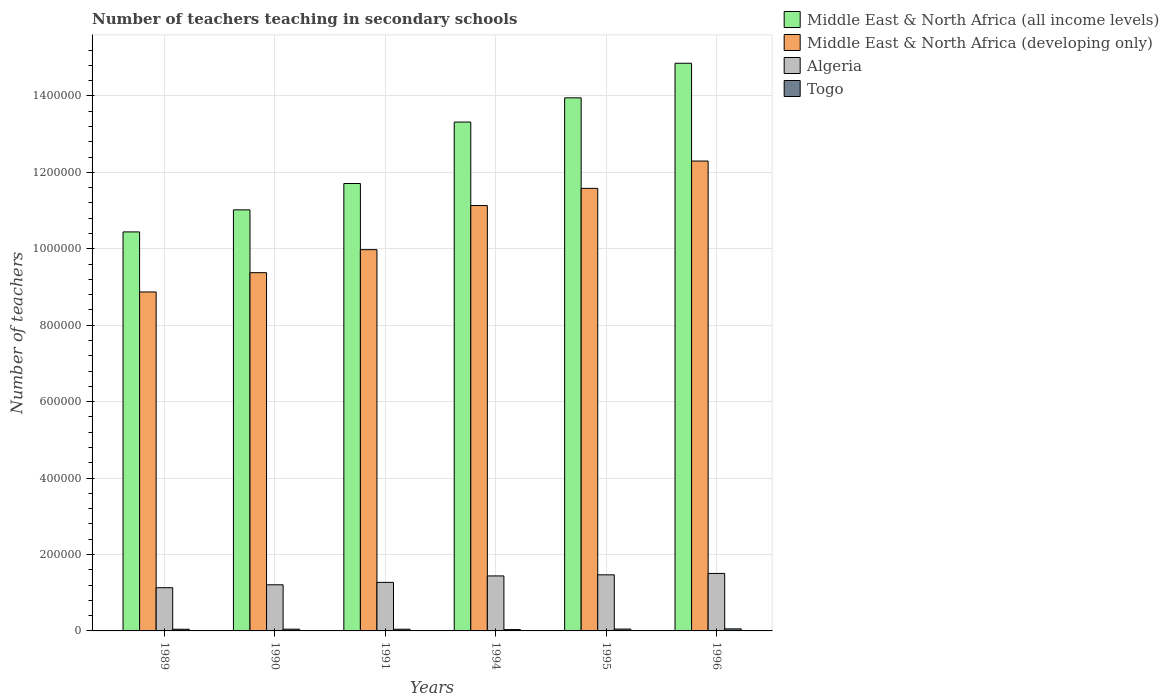How many groups of bars are there?
Your answer should be compact. 6. Are the number of bars per tick equal to the number of legend labels?
Provide a short and direct response. Yes. How many bars are there on the 6th tick from the right?
Provide a succinct answer. 4. What is the label of the 6th group of bars from the left?
Give a very brief answer. 1996. What is the number of teachers teaching in secondary schools in Middle East & North Africa (all income levels) in 1995?
Give a very brief answer. 1.39e+06. Across all years, what is the maximum number of teachers teaching in secondary schools in Togo?
Offer a terse response. 5389. Across all years, what is the minimum number of teachers teaching in secondary schools in Algeria?
Your response must be concise. 1.13e+05. What is the total number of teachers teaching in secondary schools in Togo in the graph?
Your answer should be compact. 2.72e+04. What is the difference between the number of teachers teaching in secondary schools in Middle East & North Africa (all income levels) in 1991 and that in 1996?
Your response must be concise. -3.15e+05. What is the difference between the number of teachers teaching in secondary schools in Togo in 1991 and the number of teachers teaching in secondary schools in Middle East & North Africa (all income levels) in 1996?
Your answer should be compact. -1.48e+06. What is the average number of teachers teaching in secondary schools in Middle East & North Africa (all income levels) per year?
Provide a succinct answer. 1.25e+06. In the year 1990, what is the difference between the number of teachers teaching in secondary schools in Togo and number of teachers teaching in secondary schools in Algeria?
Make the answer very short. -1.16e+05. In how many years, is the number of teachers teaching in secondary schools in Middle East & North Africa (developing only) greater than 200000?
Your response must be concise. 6. What is the ratio of the number of teachers teaching in secondary schools in Middle East & North Africa (all income levels) in 1990 to that in 1991?
Make the answer very short. 0.94. Is the number of teachers teaching in secondary schools in Middle East & North Africa (all income levels) in 1994 less than that in 1995?
Make the answer very short. Yes. What is the difference between the highest and the second highest number of teachers teaching in secondary schools in Middle East & North Africa (all income levels)?
Offer a terse response. 9.05e+04. What is the difference between the highest and the lowest number of teachers teaching in secondary schools in Middle East & North Africa (developing only)?
Ensure brevity in your answer.  3.43e+05. In how many years, is the number of teachers teaching in secondary schools in Algeria greater than the average number of teachers teaching in secondary schools in Algeria taken over all years?
Your answer should be very brief. 3. Is the sum of the number of teachers teaching in secondary schools in Algeria in 1991 and 1996 greater than the maximum number of teachers teaching in secondary schools in Middle East & North Africa (all income levels) across all years?
Provide a succinct answer. No. What does the 2nd bar from the left in 1995 represents?
Offer a terse response. Middle East & North Africa (developing only). What does the 3rd bar from the right in 1989 represents?
Offer a very short reply. Middle East & North Africa (developing only). Is it the case that in every year, the sum of the number of teachers teaching in secondary schools in Algeria and number of teachers teaching in secondary schools in Middle East & North Africa (all income levels) is greater than the number of teachers teaching in secondary schools in Togo?
Your answer should be compact. Yes. How many bars are there?
Make the answer very short. 24. What is the difference between two consecutive major ticks on the Y-axis?
Keep it short and to the point. 2.00e+05. Are the values on the major ticks of Y-axis written in scientific E-notation?
Your response must be concise. No. Does the graph contain grids?
Give a very brief answer. Yes. How are the legend labels stacked?
Provide a succinct answer. Vertical. What is the title of the graph?
Offer a terse response. Number of teachers teaching in secondary schools. What is the label or title of the X-axis?
Provide a short and direct response. Years. What is the label or title of the Y-axis?
Provide a short and direct response. Number of teachers. What is the Number of teachers in Middle East & North Africa (all income levels) in 1989?
Make the answer very short. 1.04e+06. What is the Number of teachers in Middle East & North Africa (developing only) in 1989?
Provide a succinct answer. 8.87e+05. What is the Number of teachers of Algeria in 1989?
Make the answer very short. 1.13e+05. What is the Number of teachers in Togo in 1989?
Make the answer very short. 4423. What is the Number of teachers of Middle East & North Africa (all income levels) in 1990?
Your answer should be very brief. 1.10e+06. What is the Number of teachers of Middle East & North Africa (developing only) in 1990?
Provide a short and direct response. 9.37e+05. What is the Number of teachers in Algeria in 1990?
Your answer should be compact. 1.21e+05. What is the Number of teachers in Togo in 1990?
Your response must be concise. 4553. What is the Number of teachers of Middle East & North Africa (all income levels) in 1991?
Provide a short and direct response. 1.17e+06. What is the Number of teachers of Middle East & North Africa (developing only) in 1991?
Make the answer very short. 9.98e+05. What is the Number of teachers of Algeria in 1991?
Make the answer very short. 1.27e+05. What is the Number of teachers of Togo in 1991?
Keep it short and to the point. 4492. What is the Number of teachers in Middle East & North Africa (all income levels) in 1994?
Your answer should be compact. 1.33e+06. What is the Number of teachers of Middle East & North Africa (developing only) in 1994?
Keep it short and to the point. 1.11e+06. What is the Number of teachers in Algeria in 1994?
Provide a succinct answer. 1.44e+05. What is the Number of teachers in Togo in 1994?
Offer a very short reply. 3513. What is the Number of teachers of Middle East & North Africa (all income levels) in 1995?
Offer a very short reply. 1.39e+06. What is the Number of teachers in Middle East & North Africa (developing only) in 1995?
Your response must be concise. 1.16e+06. What is the Number of teachers of Algeria in 1995?
Provide a succinct answer. 1.47e+05. What is the Number of teachers in Togo in 1995?
Make the answer very short. 4847. What is the Number of teachers of Middle East & North Africa (all income levels) in 1996?
Provide a short and direct response. 1.49e+06. What is the Number of teachers in Middle East & North Africa (developing only) in 1996?
Your response must be concise. 1.23e+06. What is the Number of teachers of Algeria in 1996?
Make the answer very short. 1.50e+05. What is the Number of teachers of Togo in 1996?
Ensure brevity in your answer.  5389. Across all years, what is the maximum Number of teachers in Middle East & North Africa (all income levels)?
Provide a short and direct response. 1.49e+06. Across all years, what is the maximum Number of teachers of Middle East & North Africa (developing only)?
Provide a succinct answer. 1.23e+06. Across all years, what is the maximum Number of teachers of Algeria?
Your answer should be very brief. 1.50e+05. Across all years, what is the maximum Number of teachers in Togo?
Provide a succinct answer. 5389. Across all years, what is the minimum Number of teachers in Middle East & North Africa (all income levels)?
Your response must be concise. 1.04e+06. Across all years, what is the minimum Number of teachers of Middle East & North Africa (developing only)?
Offer a terse response. 8.87e+05. Across all years, what is the minimum Number of teachers in Algeria?
Give a very brief answer. 1.13e+05. Across all years, what is the minimum Number of teachers of Togo?
Ensure brevity in your answer.  3513. What is the total Number of teachers in Middle East & North Africa (all income levels) in the graph?
Your answer should be very brief. 7.53e+06. What is the total Number of teachers in Middle East & North Africa (developing only) in the graph?
Your answer should be compact. 6.32e+06. What is the total Number of teachers in Algeria in the graph?
Offer a terse response. 8.02e+05. What is the total Number of teachers of Togo in the graph?
Give a very brief answer. 2.72e+04. What is the difference between the Number of teachers in Middle East & North Africa (all income levels) in 1989 and that in 1990?
Keep it short and to the point. -5.77e+04. What is the difference between the Number of teachers of Middle East & North Africa (developing only) in 1989 and that in 1990?
Give a very brief answer. -5.04e+04. What is the difference between the Number of teachers in Algeria in 1989 and that in 1990?
Give a very brief answer. -7623. What is the difference between the Number of teachers of Togo in 1989 and that in 1990?
Your answer should be compact. -130. What is the difference between the Number of teachers of Middle East & North Africa (all income levels) in 1989 and that in 1991?
Give a very brief answer. -1.27e+05. What is the difference between the Number of teachers in Middle East & North Africa (developing only) in 1989 and that in 1991?
Offer a very short reply. -1.11e+05. What is the difference between the Number of teachers in Algeria in 1989 and that in 1991?
Provide a succinct answer. -1.39e+04. What is the difference between the Number of teachers of Togo in 1989 and that in 1991?
Give a very brief answer. -69. What is the difference between the Number of teachers of Middle East & North Africa (all income levels) in 1989 and that in 1994?
Provide a short and direct response. -2.87e+05. What is the difference between the Number of teachers in Middle East & North Africa (developing only) in 1989 and that in 1994?
Your answer should be very brief. -2.26e+05. What is the difference between the Number of teachers in Algeria in 1989 and that in 1994?
Keep it short and to the point. -3.08e+04. What is the difference between the Number of teachers in Togo in 1989 and that in 1994?
Ensure brevity in your answer.  910. What is the difference between the Number of teachers of Middle East & North Africa (all income levels) in 1989 and that in 1995?
Keep it short and to the point. -3.51e+05. What is the difference between the Number of teachers in Middle East & North Africa (developing only) in 1989 and that in 1995?
Your answer should be compact. -2.71e+05. What is the difference between the Number of teachers in Algeria in 1989 and that in 1995?
Offer a terse response. -3.37e+04. What is the difference between the Number of teachers of Togo in 1989 and that in 1995?
Keep it short and to the point. -424. What is the difference between the Number of teachers of Middle East & North Africa (all income levels) in 1989 and that in 1996?
Offer a very short reply. -4.41e+05. What is the difference between the Number of teachers of Middle East & North Africa (developing only) in 1989 and that in 1996?
Your answer should be compact. -3.43e+05. What is the difference between the Number of teachers in Algeria in 1989 and that in 1996?
Your response must be concise. -3.73e+04. What is the difference between the Number of teachers of Togo in 1989 and that in 1996?
Offer a terse response. -966. What is the difference between the Number of teachers of Middle East & North Africa (all income levels) in 1990 and that in 1991?
Ensure brevity in your answer.  -6.90e+04. What is the difference between the Number of teachers in Middle East & North Africa (developing only) in 1990 and that in 1991?
Keep it short and to the point. -6.02e+04. What is the difference between the Number of teachers of Algeria in 1990 and that in 1991?
Your response must be concise. -6302. What is the difference between the Number of teachers in Middle East & North Africa (all income levels) in 1990 and that in 1994?
Provide a succinct answer. -2.30e+05. What is the difference between the Number of teachers of Middle East & North Africa (developing only) in 1990 and that in 1994?
Offer a very short reply. -1.76e+05. What is the difference between the Number of teachers of Algeria in 1990 and that in 1994?
Your answer should be compact. -2.32e+04. What is the difference between the Number of teachers of Togo in 1990 and that in 1994?
Ensure brevity in your answer.  1040. What is the difference between the Number of teachers of Middle East & North Africa (all income levels) in 1990 and that in 1995?
Your response must be concise. -2.93e+05. What is the difference between the Number of teachers of Middle East & North Africa (developing only) in 1990 and that in 1995?
Provide a short and direct response. -2.21e+05. What is the difference between the Number of teachers in Algeria in 1990 and that in 1995?
Provide a succinct answer. -2.61e+04. What is the difference between the Number of teachers of Togo in 1990 and that in 1995?
Give a very brief answer. -294. What is the difference between the Number of teachers in Middle East & North Africa (all income levels) in 1990 and that in 1996?
Your answer should be very brief. -3.84e+05. What is the difference between the Number of teachers of Middle East & North Africa (developing only) in 1990 and that in 1996?
Offer a very short reply. -2.92e+05. What is the difference between the Number of teachers of Algeria in 1990 and that in 1996?
Ensure brevity in your answer.  -2.97e+04. What is the difference between the Number of teachers in Togo in 1990 and that in 1996?
Offer a very short reply. -836. What is the difference between the Number of teachers of Middle East & North Africa (all income levels) in 1991 and that in 1994?
Provide a short and direct response. -1.61e+05. What is the difference between the Number of teachers of Middle East & North Africa (developing only) in 1991 and that in 1994?
Your response must be concise. -1.16e+05. What is the difference between the Number of teachers in Algeria in 1991 and that in 1994?
Make the answer very short. -1.69e+04. What is the difference between the Number of teachers in Togo in 1991 and that in 1994?
Make the answer very short. 979. What is the difference between the Number of teachers in Middle East & North Africa (all income levels) in 1991 and that in 1995?
Provide a short and direct response. -2.24e+05. What is the difference between the Number of teachers in Middle East & North Africa (developing only) in 1991 and that in 1995?
Keep it short and to the point. -1.60e+05. What is the difference between the Number of teachers in Algeria in 1991 and that in 1995?
Your answer should be compact. -1.98e+04. What is the difference between the Number of teachers in Togo in 1991 and that in 1995?
Provide a succinct answer. -355. What is the difference between the Number of teachers in Middle East & North Africa (all income levels) in 1991 and that in 1996?
Provide a succinct answer. -3.15e+05. What is the difference between the Number of teachers of Middle East & North Africa (developing only) in 1991 and that in 1996?
Provide a succinct answer. -2.32e+05. What is the difference between the Number of teachers of Algeria in 1991 and that in 1996?
Your answer should be very brief. -2.34e+04. What is the difference between the Number of teachers in Togo in 1991 and that in 1996?
Keep it short and to the point. -897. What is the difference between the Number of teachers in Middle East & North Africa (all income levels) in 1994 and that in 1995?
Keep it short and to the point. -6.34e+04. What is the difference between the Number of teachers in Middle East & North Africa (developing only) in 1994 and that in 1995?
Ensure brevity in your answer.  -4.49e+04. What is the difference between the Number of teachers in Algeria in 1994 and that in 1995?
Your response must be concise. -2905. What is the difference between the Number of teachers of Togo in 1994 and that in 1995?
Provide a succinct answer. -1334. What is the difference between the Number of teachers of Middle East & North Africa (all income levels) in 1994 and that in 1996?
Your answer should be compact. -1.54e+05. What is the difference between the Number of teachers of Middle East & North Africa (developing only) in 1994 and that in 1996?
Provide a succinct answer. -1.16e+05. What is the difference between the Number of teachers of Algeria in 1994 and that in 1996?
Ensure brevity in your answer.  -6510. What is the difference between the Number of teachers of Togo in 1994 and that in 1996?
Your answer should be very brief. -1876. What is the difference between the Number of teachers of Middle East & North Africa (all income levels) in 1995 and that in 1996?
Ensure brevity in your answer.  -9.05e+04. What is the difference between the Number of teachers of Middle East & North Africa (developing only) in 1995 and that in 1996?
Provide a succinct answer. -7.15e+04. What is the difference between the Number of teachers of Algeria in 1995 and that in 1996?
Provide a succinct answer. -3605. What is the difference between the Number of teachers of Togo in 1995 and that in 1996?
Your answer should be very brief. -542. What is the difference between the Number of teachers of Middle East & North Africa (all income levels) in 1989 and the Number of teachers of Middle East & North Africa (developing only) in 1990?
Ensure brevity in your answer.  1.07e+05. What is the difference between the Number of teachers of Middle East & North Africa (all income levels) in 1989 and the Number of teachers of Algeria in 1990?
Offer a very short reply. 9.23e+05. What is the difference between the Number of teachers in Middle East & North Africa (all income levels) in 1989 and the Number of teachers in Togo in 1990?
Your answer should be compact. 1.04e+06. What is the difference between the Number of teachers of Middle East & North Africa (developing only) in 1989 and the Number of teachers of Algeria in 1990?
Your response must be concise. 7.66e+05. What is the difference between the Number of teachers of Middle East & North Africa (developing only) in 1989 and the Number of teachers of Togo in 1990?
Ensure brevity in your answer.  8.82e+05. What is the difference between the Number of teachers of Algeria in 1989 and the Number of teachers of Togo in 1990?
Provide a succinct answer. 1.09e+05. What is the difference between the Number of teachers of Middle East & North Africa (all income levels) in 1989 and the Number of teachers of Middle East & North Africa (developing only) in 1991?
Offer a very short reply. 4.65e+04. What is the difference between the Number of teachers in Middle East & North Africa (all income levels) in 1989 and the Number of teachers in Algeria in 1991?
Provide a succinct answer. 9.17e+05. What is the difference between the Number of teachers in Middle East & North Africa (all income levels) in 1989 and the Number of teachers in Togo in 1991?
Offer a terse response. 1.04e+06. What is the difference between the Number of teachers in Middle East & North Africa (developing only) in 1989 and the Number of teachers in Algeria in 1991?
Offer a terse response. 7.60e+05. What is the difference between the Number of teachers of Middle East & North Africa (developing only) in 1989 and the Number of teachers of Togo in 1991?
Make the answer very short. 8.82e+05. What is the difference between the Number of teachers in Algeria in 1989 and the Number of teachers in Togo in 1991?
Ensure brevity in your answer.  1.09e+05. What is the difference between the Number of teachers of Middle East & North Africa (all income levels) in 1989 and the Number of teachers of Middle East & North Africa (developing only) in 1994?
Make the answer very short. -6.90e+04. What is the difference between the Number of teachers of Middle East & North Africa (all income levels) in 1989 and the Number of teachers of Algeria in 1994?
Your answer should be very brief. 9.00e+05. What is the difference between the Number of teachers in Middle East & North Africa (all income levels) in 1989 and the Number of teachers in Togo in 1994?
Make the answer very short. 1.04e+06. What is the difference between the Number of teachers in Middle East & North Africa (developing only) in 1989 and the Number of teachers in Algeria in 1994?
Give a very brief answer. 7.43e+05. What is the difference between the Number of teachers of Middle East & North Africa (developing only) in 1989 and the Number of teachers of Togo in 1994?
Your response must be concise. 8.83e+05. What is the difference between the Number of teachers of Algeria in 1989 and the Number of teachers of Togo in 1994?
Your response must be concise. 1.10e+05. What is the difference between the Number of teachers in Middle East & North Africa (all income levels) in 1989 and the Number of teachers in Middle East & North Africa (developing only) in 1995?
Provide a succinct answer. -1.14e+05. What is the difference between the Number of teachers of Middle East & North Africa (all income levels) in 1989 and the Number of teachers of Algeria in 1995?
Your answer should be very brief. 8.97e+05. What is the difference between the Number of teachers of Middle East & North Africa (all income levels) in 1989 and the Number of teachers of Togo in 1995?
Your response must be concise. 1.04e+06. What is the difference between the Number of teachers in Middle East & North Africa (developing only) in 1989 and the Number of teachers in Algeria in 1995?
Your response must be concise. 7.40e+05. What is the difference between the Number of teachers in Middle East & North Africa (developing only) in 1989 and the Number of teachers in Togo in 1995?
Keep it short and to the point. 8.82e+05. What is the difference between the Number of teachers of Algeria in 1989 and the Number of teachers of Togo in 1995?
Your response must be concise. 1.08e+05. What is the difference between the Number of teachers in Middle East & North Africa (all income levels) in 1989 and the Number of teachers in Middle East & North Africa (developing only) in 1996?
Provide a short and direct response. -1.85e+05. What is the difference between the Number of teachers in Middle East & North Africa (all income levels) in 1989 and the Number of teachers in Algeria in 1996?
Ensure brevity in your answer.  8.94e+05. What is the difference between the Number of teachers in Middle East & North Africa (all income levels) in 1989 and the Number of teachers in Togo in 1996?
Offer a very short reply. 1.04e+06. What is the difference between the Number of teachers in Middle East & North Africa (developing only) in 1989 and the Number of teachers in Algeria in 1996?
Offer a very short reply. 7.37e+05. What is the difference between the Number of teachers of Middle East & North Africa (developing only) in 1989 and the Number of teachers of Togo in 1996?
Offer a terse response. 8.82e+05. What is the difference between the Number of teachers in Algeria in 1989 and the Number of teachers in Togo in 1996?
Your answer should be compact. 1.08e+05. What is the difference between the Number of teachers in Middle East & North Africa (all income levels) in 1990 and the Number of teachers in Middle East & North Africa (developing only) in 1991?
Give a very brief answer. 1.04e+05. What is the difference between the Number of teachers in Middle East & North Africa (all income levels) in 1990 and the Number of teachers in Algeria in 1991?
Your response must be concise. 9.75e+05. What is the difference between the Number of teachers in Middle East & North Africa (all income levels) in 1990 and the Number of teachers in Togo in 1991?
Make the answer very short. 1.10e+06. What is the difference between the Number of teachers in Middle East & North Africa (developing only) in 1990 and the Number of teachers in Algeria in 1991?
Give a very brief answer. 8.10e+05. What is the difference between the Number of teachers in Middle East & North Africa (developing only) in 1990 and the Number of teachers in Togo in 1991?
Give a very brief answer. 9.33e+05. What is the difference between the Number of teachers of Algeria in 1990 and the Number of teachers of Togo in 1991?
Give a very brief answer. 1.16e+05. What is the difference between the Number of teachers in Middle East & North Africa (all income levels) in 1990 and the Number of teachers in Middle East & North Africa (developing only) in 1994?
Your answer should be very brief. -1.13e+04. What is the difference between the Number of teachers in Middle East & North Africa (all income levels) in 1990 and the Number of teachers in Algeria in 1994?
Make the answer very short. 9.58e+05. What is the difference between the Number of teachers of Middle East & North Africa (all income levels) in 1990 and the Number of teachers of Togo in 1994?
Keep it short and to the point. 1.10e+06. What is the difference between the Number of teachers in Middle East & North Africa (developing only) in 1990 and the Number of teachers in Algeria in 1994?
Keep it short and to the point. 7.93e+05. What is the difference between the Number of teachers of Middle East & North Africa (developing only) in 1990 and the Number of teachers of Togo in 1994?
Offer a terse response. 9.34e+05. What is the difference between the Number of teachers of Algeria in 1990 and the Number of teachers of Togo in 1994?
Provide a succinct answer. 1.17e+05. What is the difference between the Number of teachers in Middle East & North Africa (all income levels) in 1990 and the Number of teachers in Middle East & North Africa (developing only) in 1995?
Keep it short and to the point. -5.63e+04. What is the difference between the Number of teachers of Middle East & North Africa (all income levels) in 1990 and the Number of teachers of Algeria in 1995?
Provide a short and direct response. 9.55e+05. What is the difference between the Number of teachers in Middle East & North Africa (all income levels) in 1990 and the Number of teachers in Togo in 1995?
Provide a succinct answer. 1.10e+06. What is the difference between the Number of teachers of Middle East & North Africa (developing only) in 1990 and the Number of teachers of Algeria in 1995?
Offer a very short reply. 7.91e+05. What is the difference between the Number of teachers of Middle East & North Africa (developing only) in 1990 and the Number of teachers of Togo in 1995?
Your response must be concise. 9.33e+05. What is the difference between the Number of teachers in Algeria in 1990 and the Number of teachers in Togo in 1995?
Offer a very short reply. 1.16e+05. What is the difference between the Number of teachers of Middle East & North Africa (all income levels) in 1990 and the Number of teachers of Middle East & North Africa (developing only) in 1996?
Provide a succinct answer. -1.28e+05. What is the difference between the Number of teachers of Middle East & North Africa (all income levels) in 1990 and the Number of teachers of Algeria in 1996?
Give a very brief answer. 9.51e+05. What is the difference between the Number of teachers of Middle East & North Africa (all income levels) in 1990 and the Number of teachers of Togo in 1996?
Ensure brevity in your answer.  1.10e+06. What is the difference between the Number of teachers of Middle East & North Africa (developing only) in 1990 and the Number of teachers of Algeria in 1996?
Ensure brevity in your answer.  7.87e+05. What is the difference between the Number of teachers of Middle East & North Africa (developing only) in 1990 and the Number of teachers of Togo in 1996?
Your answer should be very brief. 9.32e+05. What is the difference between the Number of teachers in Algeria in 1990 and the Number of teachers in Togo in 1996?
Your answer should be compact. 1.15e+05. What is the difference between the Number of teachers in Middle East & North Africa (all income levels) in 1991 and the Number of teachers in Middle East & North Africa (developing only) in 1994?
Provide a short and direct response. 5.76e+04. What is the difference between the Number of teachers of Middle East & North Africa (all income levels) in 1991 and the Number of teachers of Algeria in 1994?
Offer a terse response. 1.03e+06. What is the difference between the Number of teachers in Middle East & North Africa (all income levels) in 1991 and the Number of teachers in Togo in 1994?
Offer a very short reply. 1.17e+06. What is the difference between the Number of teachers of Middle East & North Africa (developing only) in 1991 and the Number of teachers of Algeria in 1994?
Your answer should be compact. 8.54e+05. What is the difference between the Number of teachers in Middle East & North Africa (developing only) in 1991 and the Number of teachers in Togo in 1994?
Provide a succinct answer. 9.94e+05. What is the difference between the Number of teachers in Algeria in 1991 and the Number of teachers in Togo in 1994?
Keep it short and to the point. 1.24e+05. What is the difference between the Number of teachers in Middle East & North Africa (all income levels) in 1991 and the Number of teachers in Middle East & North Africa (developing only) in 1995?
Give a very brief answer. 1.27e+04. What is the difference between the Number of teachers in Middle East & North Africa (all income levels) in 1991 and the Number of teachers in Algeria in 1995?
Your answer should be very brief. 1.02e+06. What is the difference between the Number of teachers of Middle East & North Africa (all income levels) in 1991 and the Number of teachers of Togo in 1995?
Offer a terse response. 1.17e+06. What is the difference between the Number of teachers in Middle East & North Africa (developing only) in 1991 and the Number of teachers in Algeria in 1995?
Your answer should be compact. 8.51e+05. What is the difference between the Number of teachers in Middle East & North Africa (developing only) in 1991 and the Number of teachers in Togo in 1995?
Provide a succinct answer. 9.93e+05. What is the difference between the Number of teachers of Algeria in 1991 and the Number of teachers of Togo in 1995?
Provide a succinct answer. 1.22e+05. What is the difference between the Number of teachers of Middle East & North Africa (all income levels) in 1991 and the Number of teachers of Middle East & North Africa (developing only) in 1996?
Your answer should be compact. -5.88e+04. What is the difference between the Number of teachers of Middle East & North Africa (all income levels) in 1991 and the Number of teachers of Algeria in 1996?
Ensure brevity in your answer.  1.02e+06. What is the difference between the Number of teachers of Middle East & North Africa (all income levels) in 1991 and the Number of teachers of Togo in 1996?
Provide a short and direct response. 1.17e+06. What is the difference between the Number of teachers of Middle East & North Africa (developing only) in 1991 and the Number of teachers of Algeria in 1996?
Keep it short and to the point. 8.47e+05. What is the difference between the Number of teachers in Middle East & North Africa (developing only) in 1991 and the Number of teachers in Togo in 1996?
Provide a succinct answer. 9.92e+05. What is the difference between the Number of teachers of Algeria in 1991 and the Number of teachers of Togo in 1996?
Keep it short and to the point. 1.22e+05. What is the difference between the Number of teachers in Middle East & North Africa (all income levels) in 1994 and the Number of teachers in Middle East & North Africa (developing only) in 1995?
Ensure brevity in your answer.  1.73e+05. What is the difference between the Number of teachers of Middle East & North Africa (all income levels) in 1994 and the Number of teachers of Algeria in 1995?
Your response must be concise. 1.18e+06. What is the difference between the Number of teachers in Middle East & North Africa (all income levels) in 1994 and the Number of teachers in Togo in 1995?
Provide a succinct answer. 1.33e+06. What is the difference between the Number of teachers of Middle East & North Africa (developing only) in 1994 and the Number of teachers of Algeria in 1995?
Keep it short and to the point. 9.66e+05. What is the difference between the Number of teachers in Middle East & North Africa (developing only) in 1994 and the Number of teachers in Togo in 1995?
Provide a short and direct response. 1.11e+06. What is the difference between the Number of teachers in Algeria in 1994 and the Number of teachers in Togo in 1995?
Ensure brevity in your answer.  1.39e+05. What is the difference between the Number of teachers of Middle East & North Africa (all income levels) in 1994 and the Number of teachers of Middle East & North Africa (developing only) in 1996?
Your response must be concise. 1.02e+05. What is the difference between the Number of teachers of Middle East & North Africa (all income levels) in 1994 and the Number of teachers of Algeria in 1996?
Keep it short and to the point. 1.18e+06. What is the difference between the Number of teachers of Middle East & North Africa (all income levels) in 1994 and the Number of teachers of Togo in 1996?
Your answer should be very brief. 1.33e+06. What is the difference between the Number of teachers of Middle East & North Africa (developing only) in 1994 and the Number of teachers of Algeria in 1996?
Give a very brief answer. 9.63e+05. What is the difference between the Number of teachers in Middle East & North Africa (developing only) in 1994 and the Number of teachers in Togo in 1996?
Provide a short and direct response. 1.11e+06. What is the difference between the Number of teachers of Algeria in 1994 and the Number of teachers of Togo in 1996?
Provide a short and direct response. 1.38e+05. What is the difference between the Number of teachers in Middle East & North Africa (all income levels) in 1995 and the Number of teachers in Middle East & North Africa (developing only) in 1996?
Offer a very short reply. 1.65e+05. What is the difference between the Number of teachers in Middle East & North Africa (all income levels) in 1995 and the Number of teachers in Algeria in 1996?
Provide a short and direct response. 1.24e+06. What is the difference between the Number of teachers of Middle East & North Africa (all income levels) in 1995 and the Number of teachers of Togo in 1996?
Provide a succinct answer. 1.39e+06. What is the difference between the Number of teachers of Middle East & North Africa (developing only) in 1995 and the Number of teachers of Algeria in 1996?
Offer a very short reply. 1.01e+06. What is the difference between the Number of teachers of Middle East & North Africa (developing only) in 1995 and the Number of teachers of Togo in 1996?
Give a very brief answer. 1.15e+06. What is the difference between the Number of teachers in Algeria in 1995 and the Number of teachers in Togo in 1996?
Provide a short and direct response. 1.41e+05. What is the average Number of teachers in Middle East & North Africa (all income levels) per year?
Keep it short and to the point. 1.25e+06. What is the average Number of teachers in Middle East & North Africa (developing only) per year?
Keep it short and to the point. 1.05e+06. What is the average Number of teachers in Algeria per year?
Make the answer very short. 1.34e+05. What is the average Number of teachers of Togo per year?
Keep it short and to the point. 4536.17. In the year 1989, what is the difference between the Number of teachers in Middle East & North Africa (all income levels) and Number of teachers in Middle East & North Africa (developing only)?
Keep it short and to the point. 1.57e+05. In the year 1989, what is the difference between the Number of teachers in Middle East & North Africa (all income levels) and Number of teachers in Algeria?
Give a very brief answer. 9.31e+05. In the year 1989, what is the difference between the Number of teachers of Middle East & North Africa (all income levels) and Number of teachers of Togo?
Provide a short and direct response. 1.04e+06. In the year 1989, what is the difference between the Number of teachers of Middle East & North Africa (developing only) and Number of teachers of Algeria?
Provide a succinct answer. 7.74e+05. In the year 1989, what is the difference between the Number of teachers of Middle East & North Africa (developing only) and Number of teachers of Togo?
Ensure brevity in your answer.  8.82e+05. In the year 1989, what is the difference between the Number of teachers in Algeria and Number of teachers in Togo?
Keep it short and to the point. 1.09e+05. In the year 1990, what is the difference between the Number of teachers of Middle East & North Africa (all income levels) and Number of teachers of Middle East & North Africa (developing only)?
Offer a very short reply. 1.64e+05. In the year 1990, what is the difference between the Number of teachers in Middle East & North Africa (all income levels) and Number of teachers in Algeria?
Offer a very short reply. 9.81e+05. In the year 1990, what is the difference between the Number of teachers in Middle East & North Africa (all income levels) and Number of teachers in Togo?
Your answer should be compact. 1.10e+06. In the year 1990, what is the difference between the Number of teachers of Middle East & North Africa (developing only) and Number of teachers of Algeria?
Your answer should be very brief. 8.17e+05. In the year 1990, what is the difference between the Number of teachers of Middle East & North Africa (developing only) and Number of teachers of Togo?
Your answer should be very brief. 9.33e+05. In the year 1990, what is the difference between the Number of teachers of Algeria and Number of teachers of Togo?
Offer a very short reply. 1.16e+05. In the year 1991, what is the difference between the Number of teachers in Middle East & North Africa (all income levels) and Number of teachers in Middle East & North Africa (developing only)?
Make the answer very short. 1.73e+05. In the year 1991, what is the difference between the Number of teachers of Middle East & North Africa (all income levels) and Number of teachers of Algeria?
Your response must be concise. 1.04e+06. In the year 1991, what is the difference between the Number of teachers in Middle East & North Africa (all income levels) and Number of teachers in Togo?
Keep it short and to the point. 1.17e+06. In the year 1991, what is the difference between the Number of teachers of Middle East & North Africa (developing only) and Number of teachers of Algeria?
Your answer should be compact. 8.71e+05. In the year 1991, what is the difference between the Number of teachers of Middle East & North Africa (developing only) and Number of teachers of Togo?
Your answer should be very brief. 9.93e+05. In the year 1991, what is the difference between the Number of teachers in Algeria and Number of teachers in Togo?
Offer a terse response. 1.23e+05. In the year 1994, what is the difference between the Number of teachers in Middle East & North Africa (all income levels) and Number of teachers in Middle East & North Africa (developing only)?
Your answer should be very brief. 2.18e+05. In the year 1994, what is the difference between the Number of teachers in Middle East & North Africa (all income levels) and Number of teachers in Algeria?
Your answer should be compact. 1.19e+06. In the year 1994, what is the difference between the Number of teachers of Middle East & North Africa (all income levels) and Number of teachers of Togo?
Offer a terse response. 1.33e+06. In the year 1994, what is the difference between the Number of teachers in Middle East & North Africa (developing only) and Number of teachers in Algeria?
Your answer should be very brief. 9.69e+05. In the year 1994, what is the difference between the Number of teachers in Middle East & North Africa (developing only) and Number of teachers in Togo?
Offer a terse response. 1.11e+06. In the year 1994, what is the difference between the Number of teachers in Algeria and Number of teachers in Togo?
Make the answer very short. 1.40e+05. In the year 1995, what is the difference between the Number of teachers of Middle East & North Africa (all income levels) and Number of teachers of Middle East & North Africa (developing only)?
Keep it short and to the point. 2.37e+05. In the year 1995, what is the difference between the Number of teachers in Middle East & North Africa (all income levels) and Number of teachers in Algeria?
Your answer should be very brief. 1.25e+06. In the year 1995, what is the difference between the Number of teachers in Middle East & North Africa (all income levels) and Number of teachers in Togo?
Provide a short and direct response. 1.39e+06. In the year 1995, what is the difference between the Number of teachers in Middle East & North Africa (developing only) and Number of teachers in Algeria?
Provide a succinct answer. 1.01e+06. In the year 1995, what is the difference between the Number of teachers of Middle East & North Africa (developing only) and Number of teachers of Togo?
Provide a short and direct response. 1.15e+06. In the year 1995, what is the difference between the Number of teachers of Algeria and Number of teachers of Togo?
Your response must be concise. 1.42e+05. In the year 1996, what is the difference between the Number of teachers in Middle East & North Africa (all income levels) and Number of teachers in Middle East & North Africa (developing only)?
Your answer should be compact. 2.56e+05. In the year 1996, what is the difference between the Number of teachers in Middle East & North Africa (all income levels) and Number of teachers in Algeria?
Your answer should be very brief. 1.33e+06. In the year 1996, what is the difference between the Number of teachers of Middle East & North Africa (all income levels) and Number of teachers of Togo?
Give a very brief answer. 1.48e+06. In the year 1996, what is the difference between the Number of teachers of Middle East & North Africa (developing only) and Number of teachers of Algeria?
Your answer should be very brief. 1.08e+06. In the year 1996, what is the difference between the Number of teachers in Middle East & North Africa (developing only) and Number of teachers in Togo?
Your answer should be very brief. 1.22e+06. In the year 1996, what is the difference between the Number of teachers in Algeria and Number of teachers in Togo?
Provide a succinct answer. 1.45e+05. What is the ratio of the Number of teachers in Middle East & North Africa (all income levels) in 1989 to that in 1990?
Give a very brief answer. 0.95. What is the ratio of the Number of teachers in Middle East & North Africa (developing only) in 1989 to that in 1990?
Offer a terse response. 0.95. What is the ratio of the Number of teachers in Algeria in 1989 to that in 1990?
Offer a terse response. 0.94. What is the ratio of the Number of teachers in Togo in 1989 to that in 1990?
Your answer should be compact. 0.97. What is the ratio of the Number of teachers in Middle East & North Africa (all income levels) in 1989 to that in 1991?
Provide a short and direct response. 0.89. What is the ratio of the Number of teachers in Middle East & North Africa (developing only) in 1989 to that in 1991?
Provide a succinct answer. 0.89. What is the ratio of the Number of teachers of Algeria in 1989 to that in 1991?
Offer a terse response. 0.89. What is the ratio of the Number of teachers in Togo in 1989 to that in 1991?
Provide a short and direct response. 0.98. What is the ratio of the Number of teachers of Middle East & North Africa (all income levels) in 1989 to that in 1994?
Give a very brief answer. 0.78. What is the ratio of the Number of teachers in Middle East & North Africa (developing only) in 1989 to that in 1994?
Your answer should be compact. 0.8. What is the ratio of the Number of teachers of Algeria in 1989 to that in 1994?
Offer a terse response. 0.79. What is the ratio of the Number of teachers of Togo in 1989 to that in 1994?
Offer a very short reply. 1.26. What is the ratio of the Number of teachers in Middle East & North Africa (all income levels) in 1989 to that in 1995?
Make the answer very short. 0.75. What is the ratio of the Number of teachers in Middle East & North Africa (developing only) in 1989 to that in 1995?
Offer a terse response. 0.77. What is the ratio of the Number of teachers of Algeria in 1989 to that in 1995?
Give a very brief answer. 0.77. What is the ratio of the Number of teachers in Togo in 1989 to that in 1995?
Give a very brief answer. 0.91. What is the ratio of the Number of teachers in Middle East & North Africa (all income levels) in 1989 to that in 1996?
Offer a terse response. 0.7. What is the ratio of the Number of teachers of Middle East & North Africa (developing only) in 1989 to that in 1996?
Ensure brevity in your answer.  0.72. What is the ratio of the Number of teachers in Algeria in 1989 to that in 1996?
Ensure brevity in your answer.  0.75. What is the ratio of the Number of teachers in Togo in 1989 to that in 1996?
Provide a succinct answer. 0.82. What is the ratio of the Number of teachers in Middle East & North Africa (all income levels) in 1990 to that in 1991?
Provide a succinct answer. 0.94. What is the ratio of the Number of teachers in Middle East & North Africa (developing only) in 1990 to that in 1991?
Give a very brief answer. 0.94. What is the ratio of the Number of teachers in Algeria in 1990 to that in 1991?
Your answer should be compact. 0.95. What is the ratio of the Number of teachers of Togo in 1990 to that in 1991?
Keep it short and to the point. 1.01. What is the ratio of the Number of teachers in Middle East & North Africa (all income levels) in 1990 to that in 1994?
Your answer should be compact. 0.83. What is the ratio of the Number of teachers of Middle East & North Africa (developing only) in 1990 to that in 1994?
Make the answer very short. 0.84. What is the ratio of the Number of teachers in Algeria in 1990 to that in 1994?
Offer a terse response. 0.84. What is the ratio of the Number of teachers in Togo in 1990 to that in 1994?
Provide a short and direct response. 1.3. What is the ratio of the Number of teachers in Middle East & North Africa (all income levels) in 1990 to that in 1995?
Your answer should be compact. 0.79. What is the ratio of the Number of teachers of Middle East & North Africa (developing only) in 1990 to that in 1995?
Provide a short and direct response. 0.81. What is the ratio of the Number of teachers of Algeria in 1990 to that in 1995?
Your answer should be compact. 0.82. What is the ratio of the Number of teachers in Togo in 1990 to that in 1995?
Give a very brief answer. 0.94. What is the ratio of the Number of teachers in Middle East & North Africa (all income levels) in 1990 to that in 1996?
Make the answer very short. 0.74. What is the ratio of the Number of teachers in Middle East & North Africa (developing only) in 1990 to that in 1996?
Your response must be concise. 0.76. What is the ratio of the Number of teachers in Algeria in 1990 to that in 1996?
Provide a short and direct response. 0.8. What is the ratio of the Number of teachers of Togo in 1990 to that in 1996?
Your answer should be compact. 0.84. What is the ratio of the Number of teachers in Middle East & North Africa (all income levels) in 1991 to that in 1994?
Your answer should be compact. 0.88. What is the ratio of the Number of teachers of Middle East & North Africa (developing only) in 1991 to that in 1994?
Your response must be concise. 0.9. What is the ratio of the Number of teachers in Algeria in 1991 to that in 1994?
Make the answer very short. 0.88. What is the ratio of the Number of teachers of Togo in 1991 to that in 1994?
Your response must be concise. 1.28. What is the ratio of the Number of teachers of Middle East & North Africa (all income levels) in 1991 to that in 1995?
Make the answer very short. 0.84. What is the ratio of the Number of teachers in Middle East & North Africa (developing only) in 1991 to that in 1995?
Give a very brief answer. 0.86. What is the ratio of the Number of teachers in Algeria in 1991 to that in 1995?
Your response must be concise. 0.87. What is the ratio of the Number of teachers in Togo in 1991 to that in 1995?
Make the answer very short. 0.93. What is the ratio of the Number of teachers of Middle East & North Africa (all income levels) in 1991 to that in 1996?
Give a very brief answer. 0.79. What is the ratio of the Number of teachers in Middle East & North Africa (developing only) in 1991 to that in 1996?
Offer a very short reply. 0.81. What is the ratio of the Number of teachers in Algeria in 1991 to that in 1996?
Provide a short and direct response. 0.84. What is the ratio of the Number of teachers in Togo in 1991 to that in 1996?
Provide a succinct answer. 0.83. What is the ratio of the Number of teachers of Middle East & North Africa (all income levels) in 1994 to that in 1995?
Offer a very short reply. 0.95. What is the ratio of the Number of teachers of Middle East & North Africa (developing only) in 1994 to that in 1995?
Provide a succinct answer. 0.96. What is the ratio of the Number of teachers in Algeria in 1994 to that in 1995?
Your response must be concise. 0.98. What is the ratio of the Number of teachers in Togo in 1994 to that in 1995?
Give a very brief answer. 0.72. What is the ratio of the Number of teachers of Middle East & North Africa (all income levels) in 1994 to that in 1996?
Provide a succinct answer. 0.9. What is the ratio of the Number of teachers in Middle East & North Africa (developing only) in 1994 to that in 1996?
Give a very brief answer. 0.91. What is the ratio of the Number of teachers of Algeria in 1994 to that in 1996?
Your answer should be compact. 0.96. What is the ratio of the Number of teachers of Togo in 1994 to that in 1996?
Your response must be concise. 0.65. What is the ratio of the Number of teachers in Middle East & North Africa (all income levels) in 1995 to that in 1996?
Provide a succinct answer. 0.94. What is the ratio of the Number of teachers of Middle East & North Africa (developing only) in 1995 to that in 1996?
Make the answer very short. 0.94. What is the ratio of the Number of teachers in Togo in 1995 to that in 1996?
Offer a very short reply. 0.9. What is the difference between the highest and the second highest Number of teachers in Middle East & North Africa (all income levels)?
Provide a short and direct response. 9.05e+04. What is the difference between the highest and the second highest Number of teachers of Middle East & North Africa (developing only)?
Your answer should be compact. 7.15e+04. What is the difference between the highest and the second highest Number of teachers in Algeria?
Give a very brief answer. 3605. What is the difference between the highest and the second highest Number of teachers of Togo?
Provide a succinct answer. 542. What is the difference between the highest and the lowest Number of teachers of Middle East & North Africa (all income levels)?
Provide a short and direct response. 4.41e+05. What is the difference between the highest and the lowest Number of teachers of Middle East & North Africa (developing only)?
Ensure brevity in your answer.  3.43e+05. What is the difference between the highest and the lowest Number of teachers of Algeria?
Keep it short and to the point. 3.73e+04. What is the difference between the highest and the lowest Number of teachers of Togo?
Give a very brief answer. 1876. 